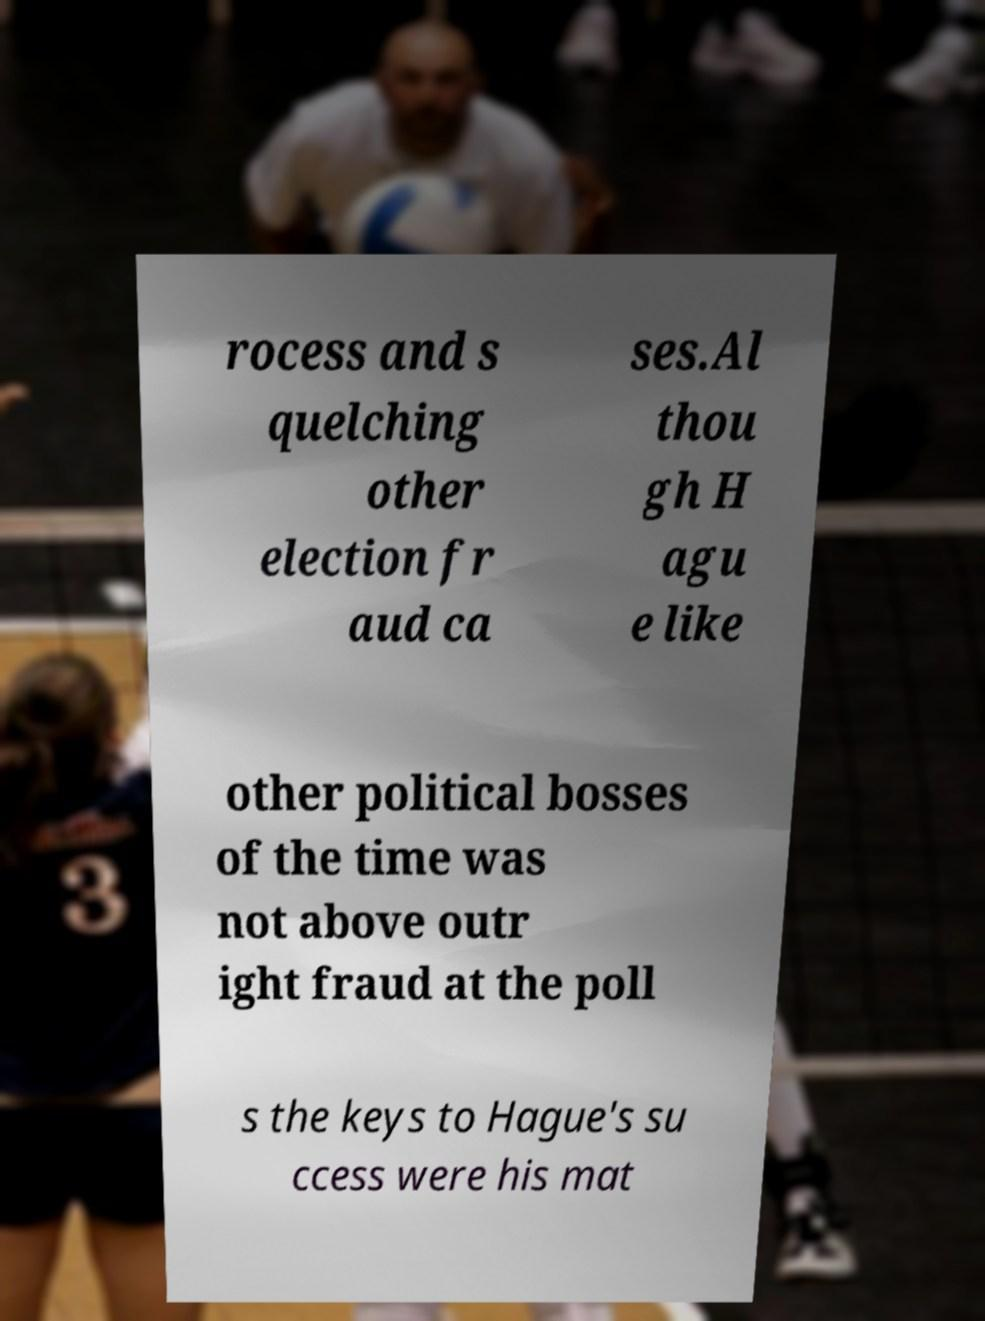Please read and relay the text visible in this image. What does it say? rocess and s quelching other election fr aud ca ses.Al thou gh H agu e like other political bosses of the time was not above outr ight fraud at the poll s the keys to Hague's su ccess were his mat 